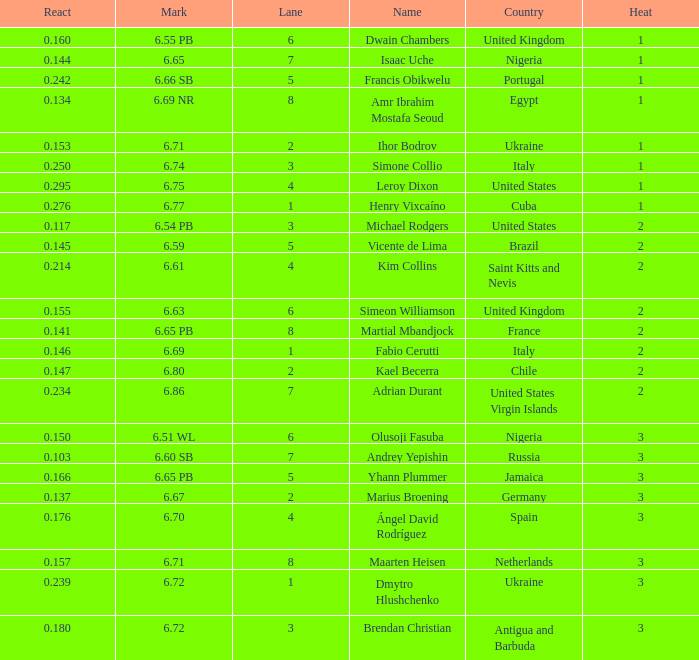What is Mark, when Name is Dmytro Hlushchenko? 6.72. 